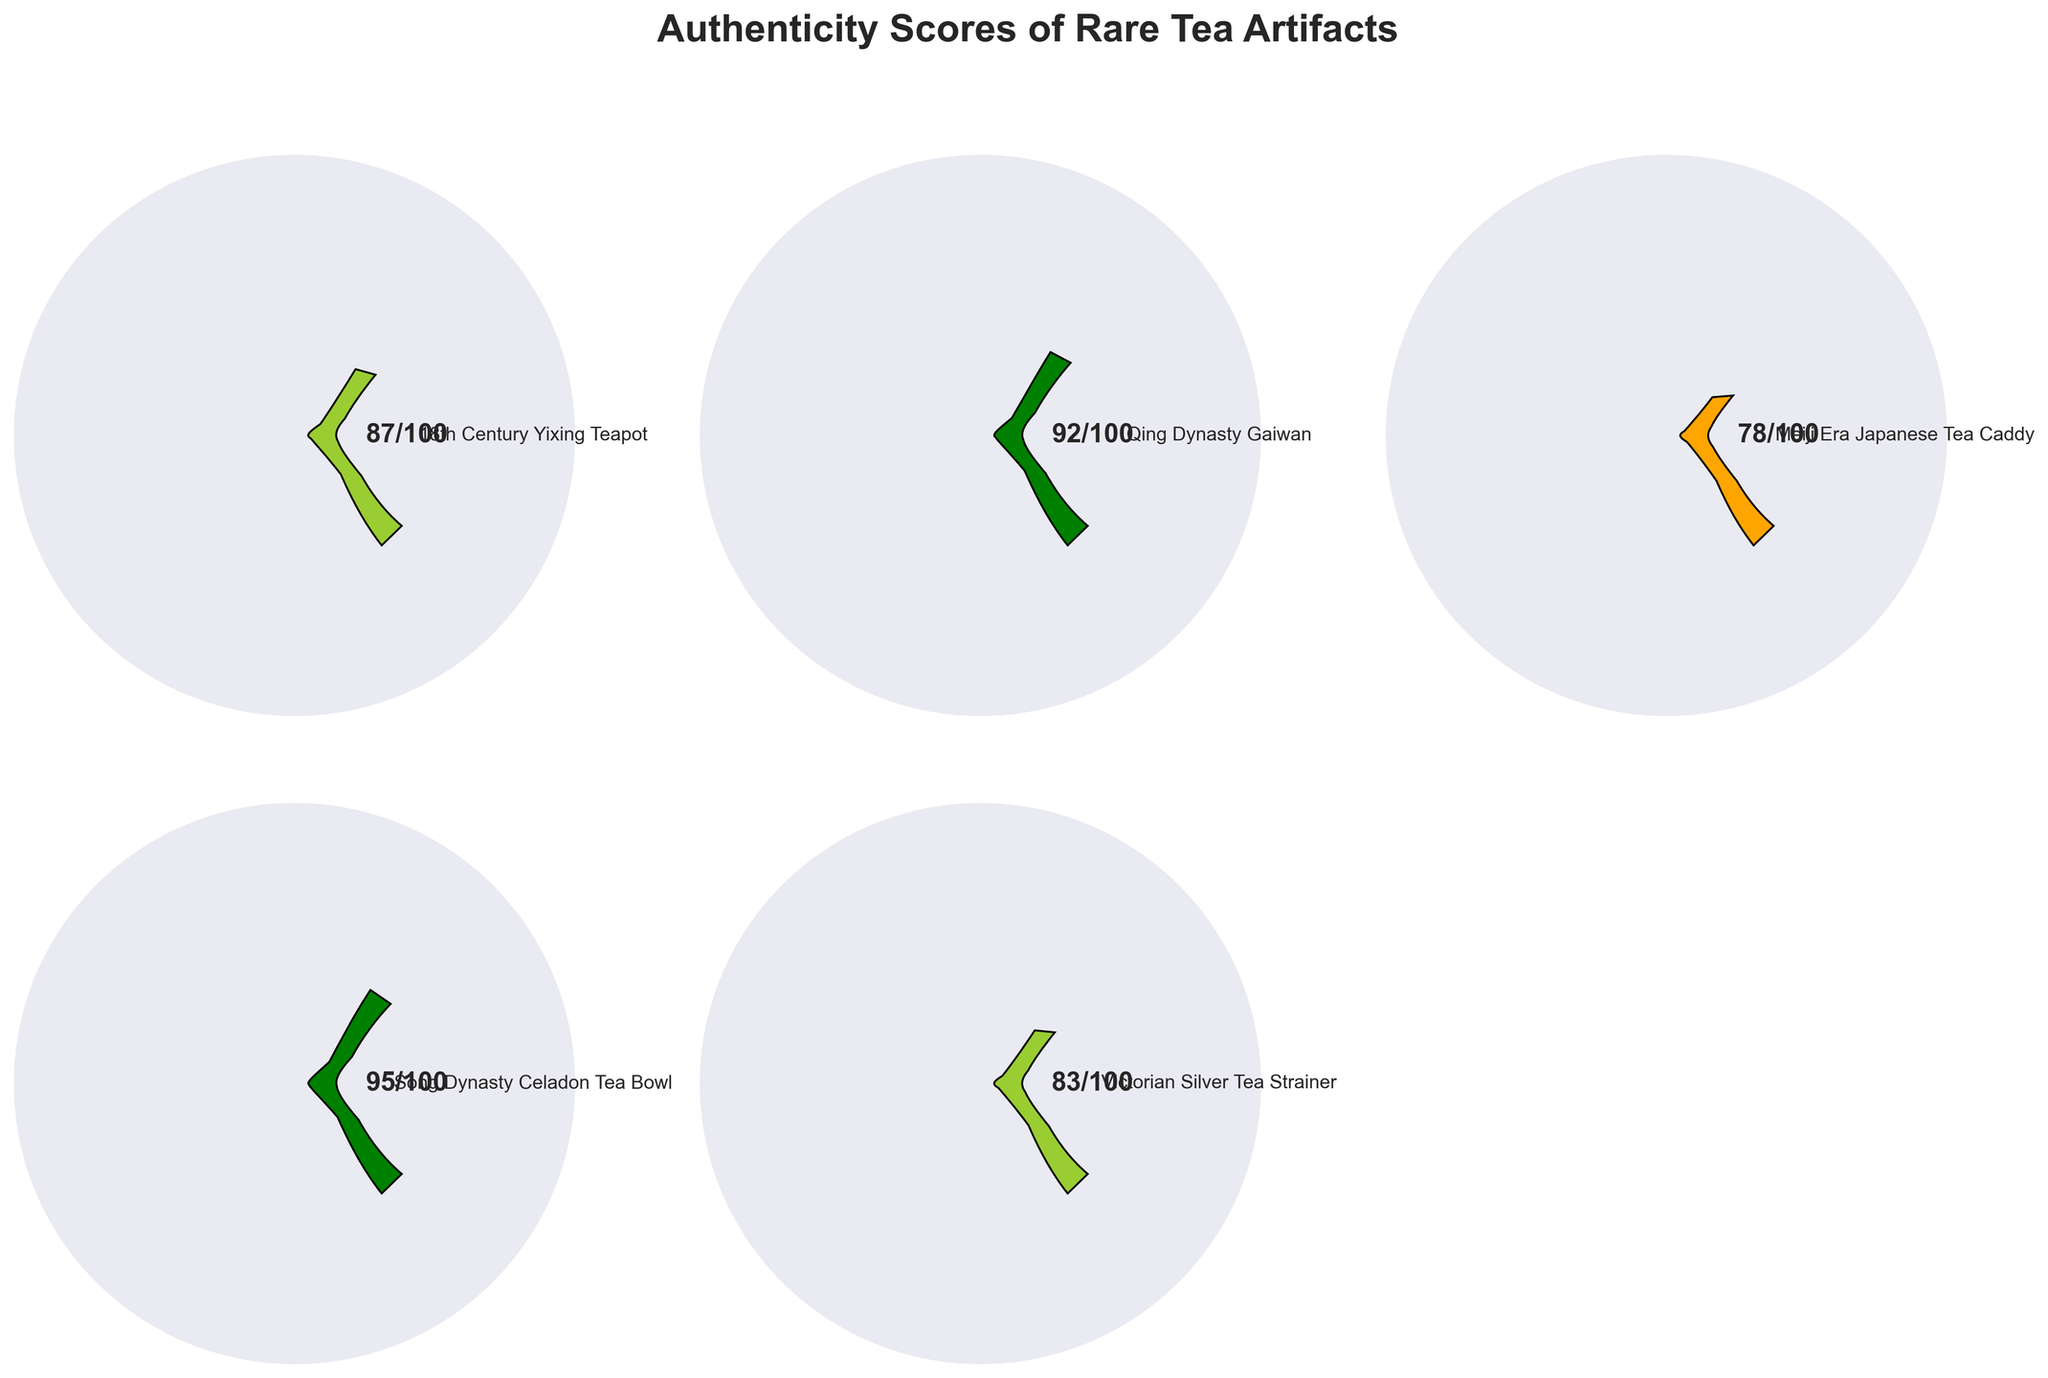What is the title of the plot? The title of the plot is displayed at the top center, reading "Authenticity Scores of Rare Tea Artifacts".
Answer: Authenticity Scores of Rare Tea Artifacts Which artifact has the highest authenticity score? The highest score is shown in the gauge that points to 95/100. This artifact is the "Song Dynasty Celadon Tea Bowl".
Answer: Song Dynasty Celadon Tea Bowl How many artifacts are evaluated on this plot? There are five gauges in total representing five different artifacts. Only five data points are plotted on this figure.
Answer: 5 What color is associated with the Qing Dynasty Gaiwan's authenticity score? The gauge corresponding to the Qing Dynasty Gaiwan is color-coded green, indicating a high authenticity score of 92.
Answer: Green What is the color indication for a score above 90? Gauges with scores above 90 are colored green. This is observed in the case of Qing Dynasty Gaiwan and Song Dynasty Celadon Tea Bowl.
Answer: Green Which artifacts have an authenticity score less than 80? Checking all gauges, the artifact with a score less than 80 is "Meiji Era Japanese Tea Caddy" with a score of 78.
Answer: Meiji Era Japanese Tea Caddy What is the average authenticity score of all the artifacts? Add up all the scores (87 + 92 + 78 + 95 + 83) which equals 435. Dividing by the number of artifacts (5) gives 435/5 = 87.
Answer: 87 Which artifact has a lower authenticity score, Victorian Silver Tea Strainer or 18th Century Yixing Teapot? Comparing the gauges, Victorian Silver Tea Strainer has an authenticity score of 83, while 18th Century Yixing Teapot has a score of 87. Thus, Victorian Silver Tea Strainer has a lower score.
Answer: Victorian Silver Tea Strainer If the authenticity score of the Qing Dynasty Gaiwan were to increase by 5, what would be its new score and color? The current score of the Qing Dynasty Gaiwan is 92. Adding 5 results in 97. Since this is still above 90, the color remains green.
Answer: 97, green Which artifact falls in the 'yellowgreen' color code range and what is its score? The gauge for the 'yellowgreen' color is set from scores 80 to 89. The "18th Century Yixing Teapot" falls in this range with a score of 87.
Answer: 18th Century Yixing Teapot, 87 